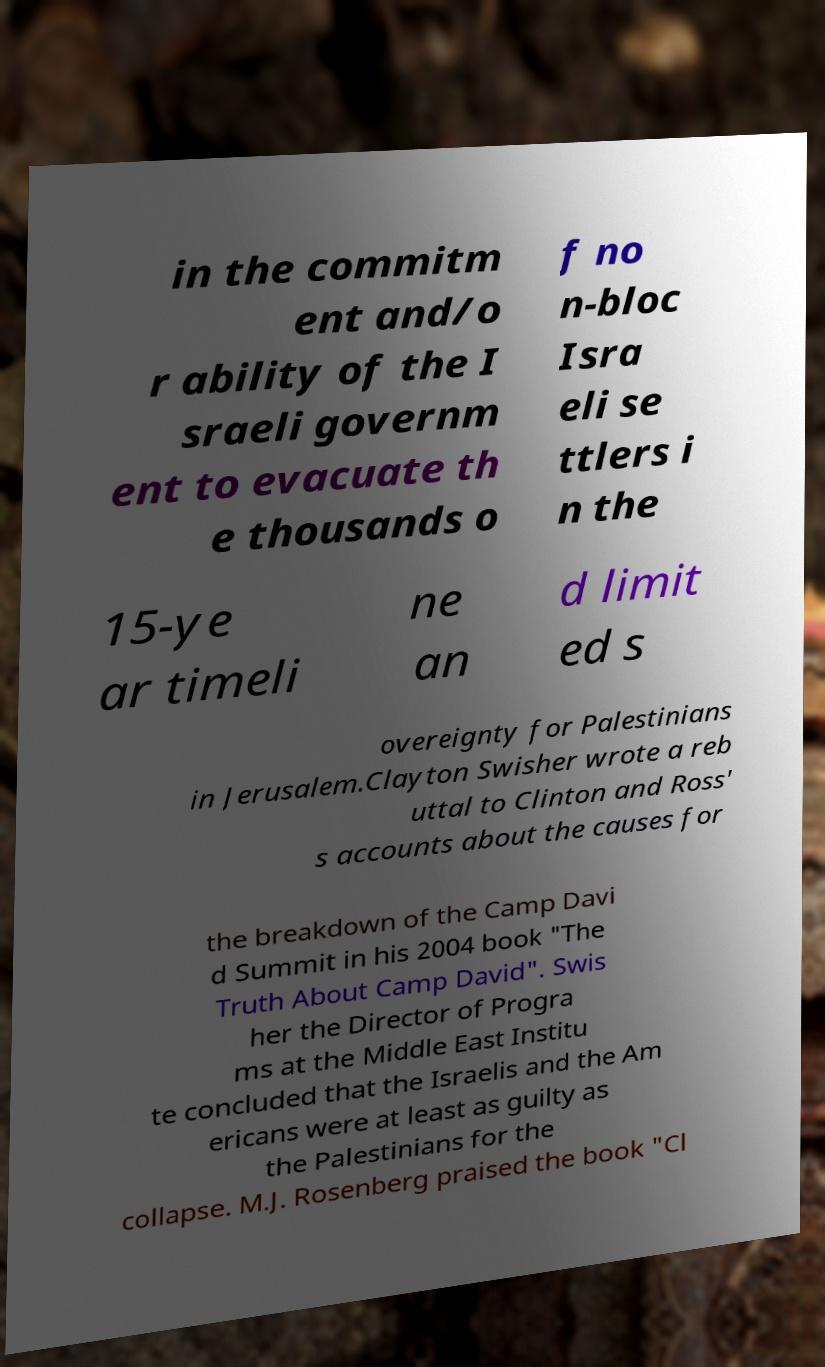Could you assist in decoding the text presented in this image and type it out clearly? in the commitm ent and/o r ability of the I sraeli governm ent to evacuate th e thousands o f no n-bloc Isra eli se ttlers i n the 15-ye ar timeli ne an d limit ed s overeignty for Palestinians in Jerusalem.Clayton Swisher wrote a reb uttal to Clinton and Ross' s accounts about the causes for the breakdown of the Camp Davi d Summit in his 2004 book "The Truth About Camp David". Swis her the Director of Progra ms at the Middle East Institu te concluded that the Israelis and the Am ericans were at least as guilty as the Palestinians for the collapse. M.J. Rosenberg praised the book "Cl 